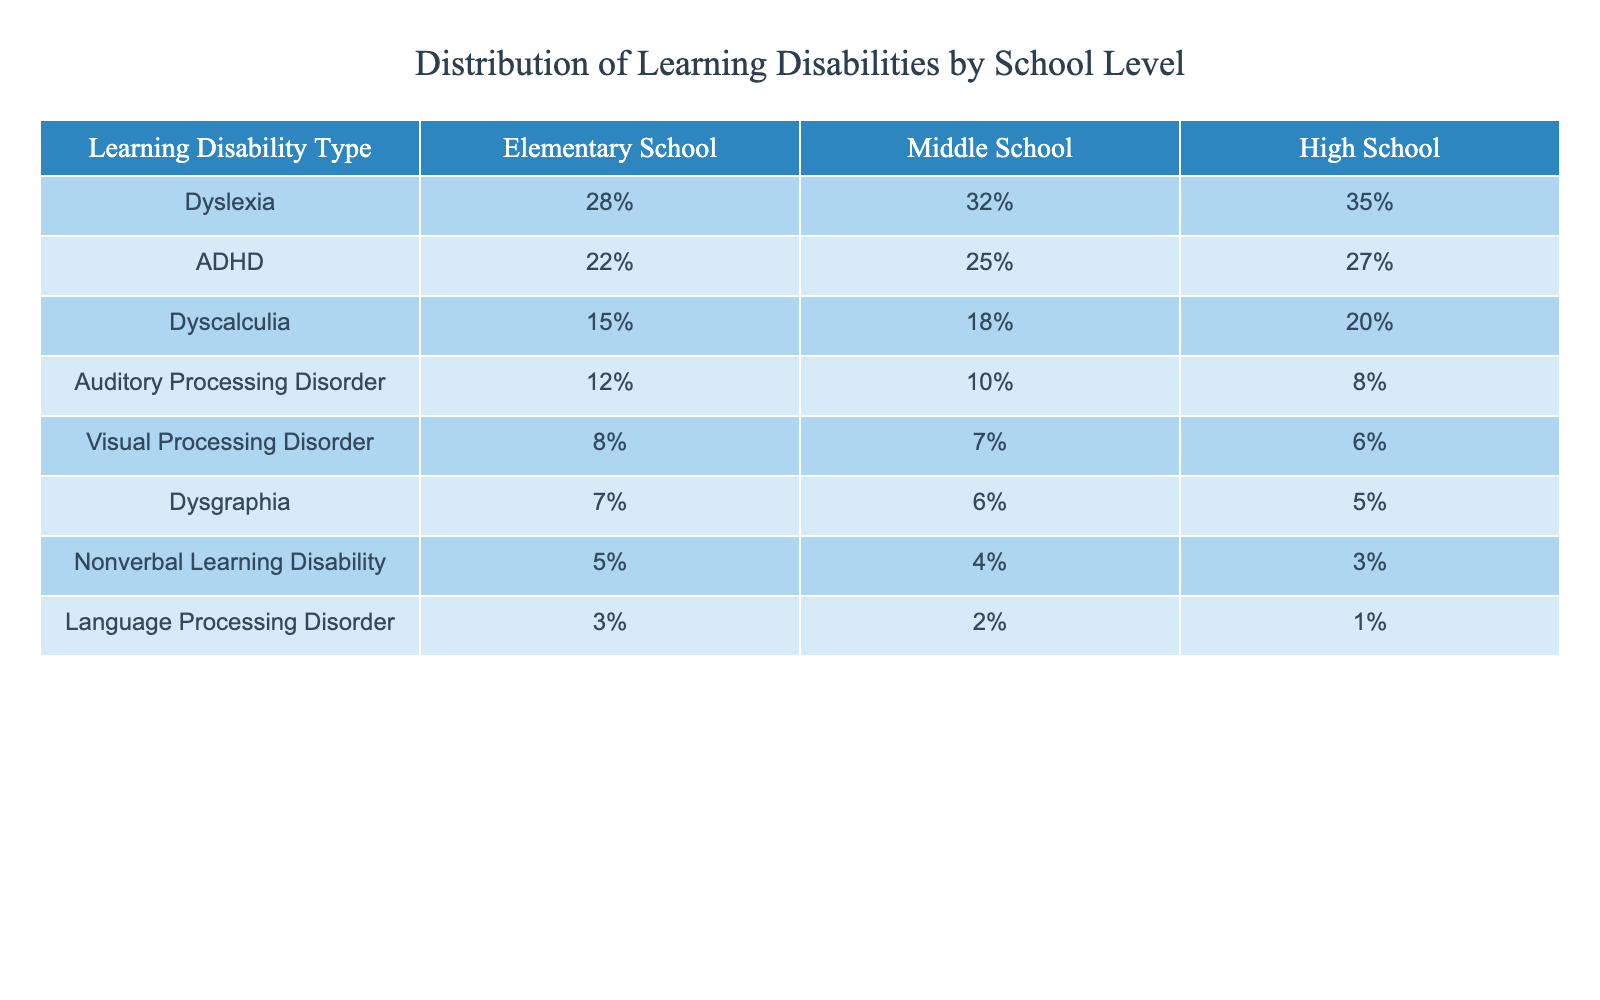What percentage of students with learning disabilities in elementary school have Dyslexia? According to the table, the percentage of students with Dyslexia in elementary schools is listed as 28%.
Answer: 28% What is the percentage of students with ADHD in high school? The table shows that 27% of students with ADHD are in high school.
Answer: 27% What is the total percentage of students with Dyscalculia across all school levels? To find the total, we add the percentages from all levels: 15% (Elementary) + 18% (Middle) + 20% (High) = 53%.
Answer: 53% Which learning disability shows the highest percentage in middle school? The highest percentage in middle school is for Dyslexia, which is 32%.
Answer: Dyslexia Is the percentage of students with Visual Processing Disorder higher in elementary or high school? By comparing the percentages, 8% in elementary is greater than 6% in high school. Therefore, it's higher in elementary.
Answer: Yes What is the decrease in percentage from elementary to high school for Auditory Processing Disorder? To find the decrease: 12% (Elementary) - 8% (High) = 4%.
Answer: 4% What is the average percentage of students with Dysgraphia across all school levels? The average is calculated by summing the percentages: (7% + 6% + 5%) / 3 = 6%.
Answer: 6% Which learning disability has the lowest percentage in high school? The table shows that Language Processing Disorder has the lowest percentage in high school at 1%.
Answer: Language Processing Disorder If you combine the percentages of Dyslexia and ADHD in elementary school, what is the total? Adding the percentages: 28% (Dyslexia) + 22% (ADHD) = 50%.
Answer: 50% How does the percentage of Nonverbal Learning Disability change from elementary to high school? The percentage decreases from 5% in elementary to 3% in high school, indicating a drop of 2%.
Answer: Decrease of 2% 